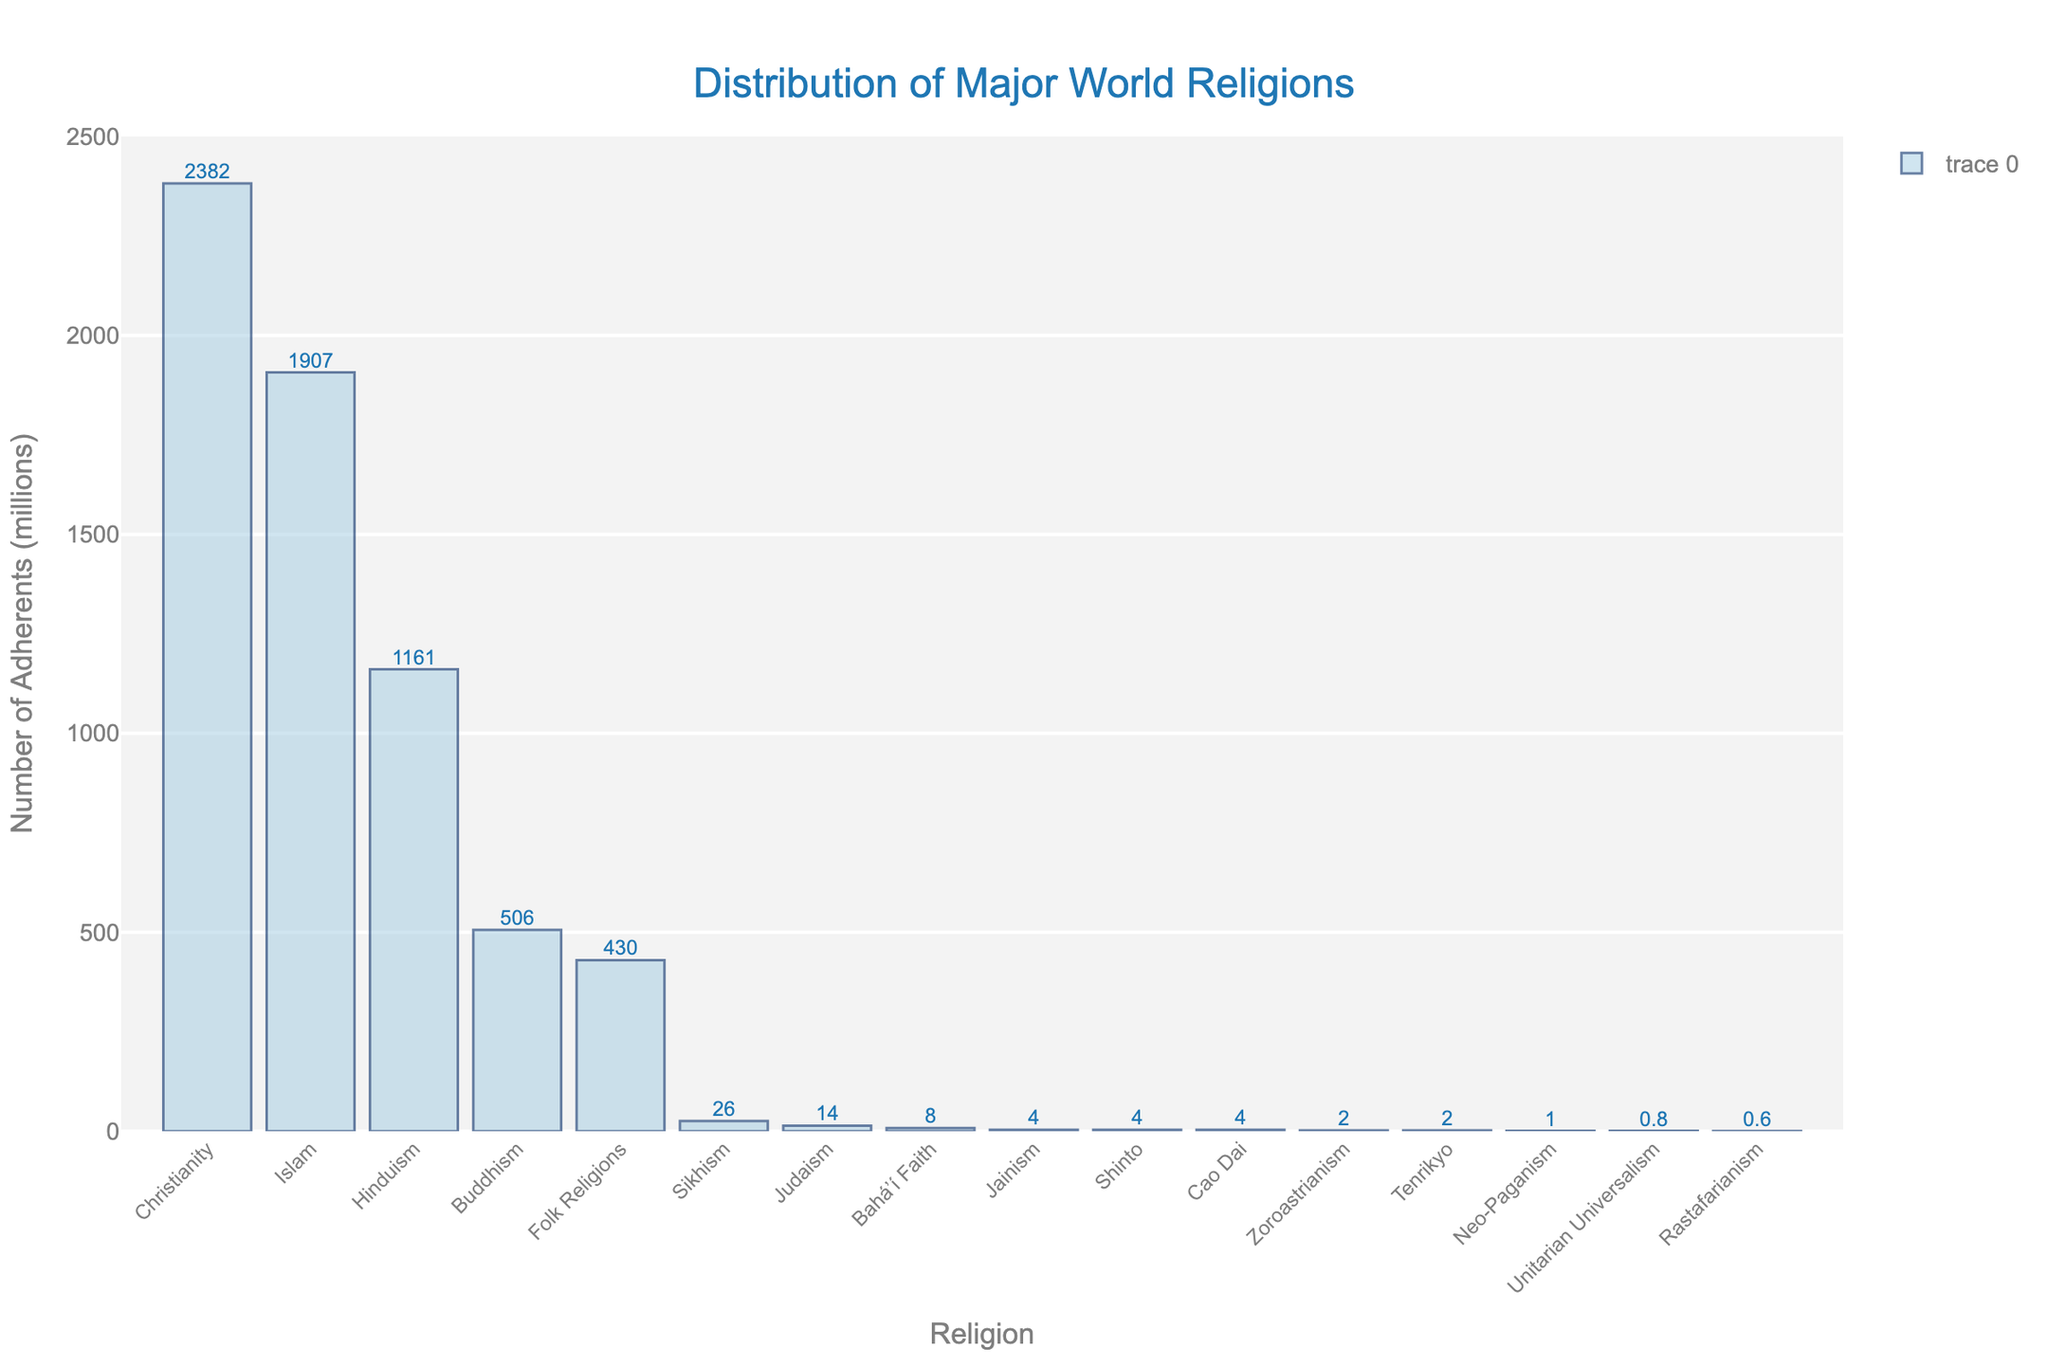Which religion has the highest number of adherents? The religion with the tallest bar represents the highest number of adherents. Christianity has the tallest bar.
Answer: Christianity Which religion has the lowest number of adherents? The religion with the shortest bar represents the lowest number of adherents. Rastafarianism has the shortest bar.
Answer: Rastafarianism How many more adherents does Christianity have compared to Islam? Look at the top two bars and find the difference in their heights. Christianity has 2382 million adherents, and Islam has 1907 million adherents, so 2382 - 1907 = 475 million.
Answer: 475 million What is the combined number of adherents for Buddhism and Hinduism? Sum the adherents for Buddhism and Hinduism. Buddhism has 506 million adherents, and Hinduism has 1161 million adherents, so 506 + 1161 = 1667 million.
Answer: 1667 million Which religions have fewer than 10 million adherents? Identify bars with values less than 10 million. These bars belong to Baháʼí Faith, Jainism, Shinto, Cao Dai, Zoroastrianism, Tenrikyo, Neo-Paganism, Unitarian Universalism, and Rastafarianism.
Answer: Baháʼí Faith, Jainism, Shinto, Cao Dai, Zoroastrianism, Tenrikyo, Neo-Paganism, Unitarian Universalism, Rastafarianism What is the median number of adherents across all religions? List the adherent values and find the middle one. Ordered adherents: 0.6, 0.8, 1, 2, 2, 4, 4, 4, 8, 14, 26, 430, 506, 1161, 1907, 2382. The median is the average of the 8th and 9th values: (4+8)/2 = 6 million.
Answer: 6 million How does the number of adherents of Sikhism compare to Folk Religions? Compare the heights of the bars for Sikhism and Folk Religions. Sikhism has 26 million adherents, while Folk Religions have 430 million adherents, so Sikhism has much fewer adherents.
Answer: Sikhism has fewer adherents What fraction of the total number of adherents does Judaism represent? Sum the adherents of all religions and then divide the adherents of Judaism by this total. Total adherents = 2382 + 1907 + 1161 + 506 + 430 + 26 + 14 + 8 + 4 + 4 + 4 + 2 + 2 + 1 + 0.8 + 0.6 = 6451.4 million. Judaism = 14/6451.4 ≈ 0.00217, or about 0.217%.
Answer: About 0.217% Which has more adherents, Buddhism or all religions with fewer than 10 million adherents combined? Sum the adherents of all religions with fewer than 10 million adherents and compare the total to Buddhism. Religions with fewer than 10 million adherents: 8 + 4 + 4 + 4 + 2 + 2 + 1 + 0.8 + 0.6 = 26.4 million. Buddhism has 506 million adherents, which is greater.
Answer: Buddhism has more adherents 